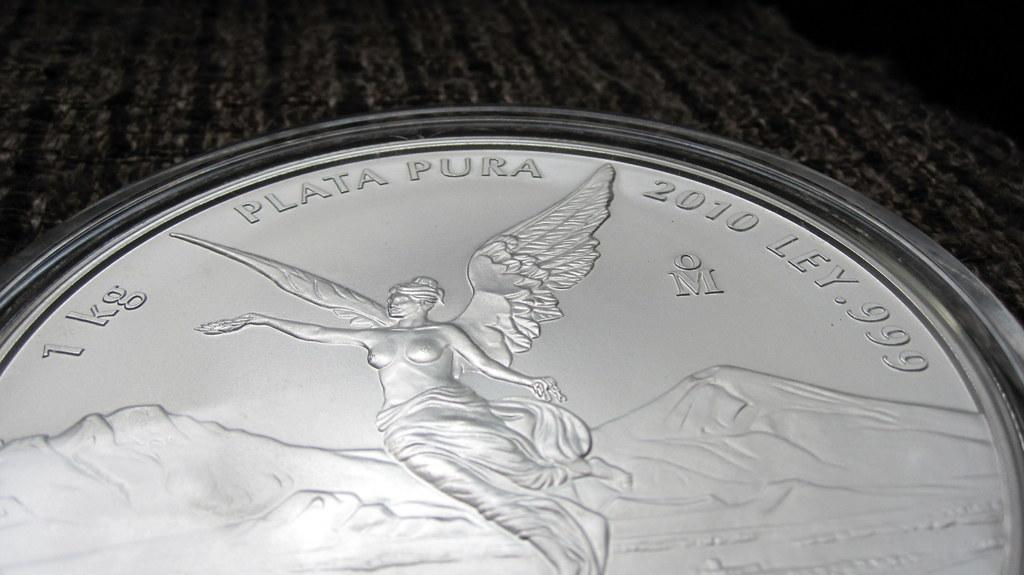<image>
Write a terse but informative summary of the picture. A 1kg Plata Pura coin featuring an angelic design is resting on a wooden surface. 